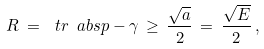<formula> <loc_0><loc_0><loc_500><loc_500>R \, = \, \ t r \ a b s { p - \gamma } \, \geq \, \frac { \sqrt { a } } { 2 } \, = \, \frac { \sqrt { E } } { 2 } \, ,</formula> 